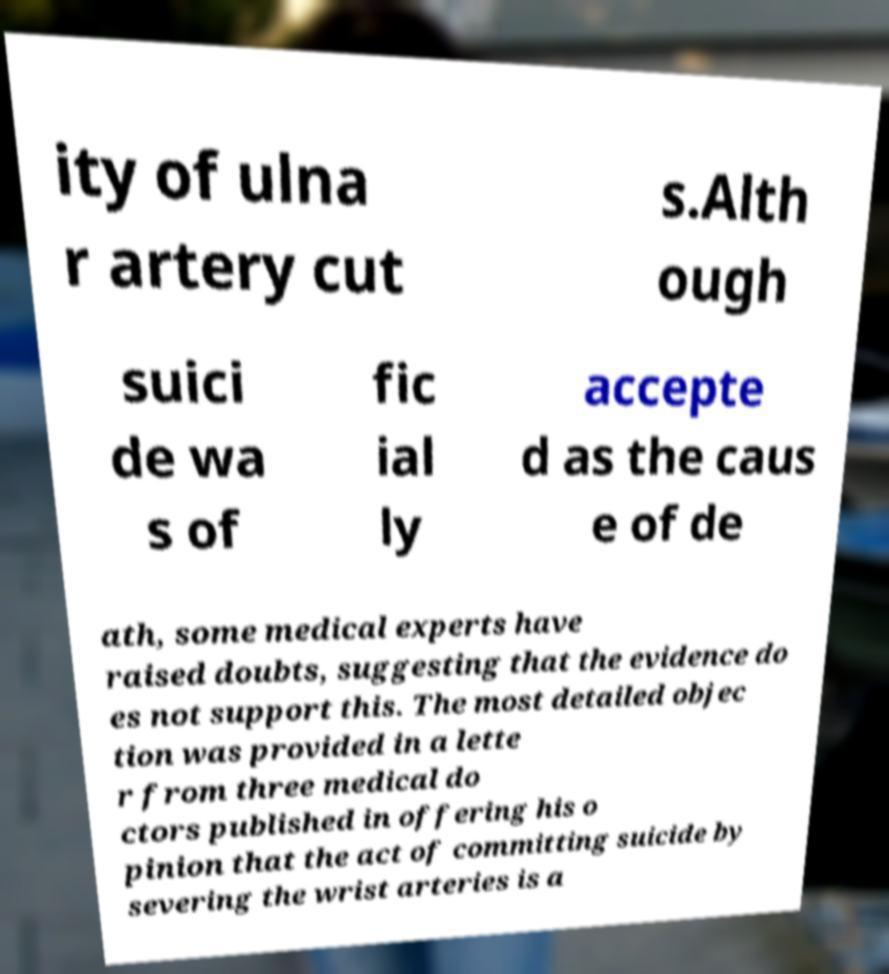There's text embedded in this image that I need extracted. Can you transcribe it verbatim? ity of ulna r artery cut s.Alth ough suici de wa s of fic ial ly accepte d as the caus e of de ath, some medical experts have raised doubts, suggesting that the evidence do es not support this. The most detailed objec tion was provided in a lette r from three medical do ctors published in offering his o pinion that the act of committing suicide by severing the wrist arteries is a 